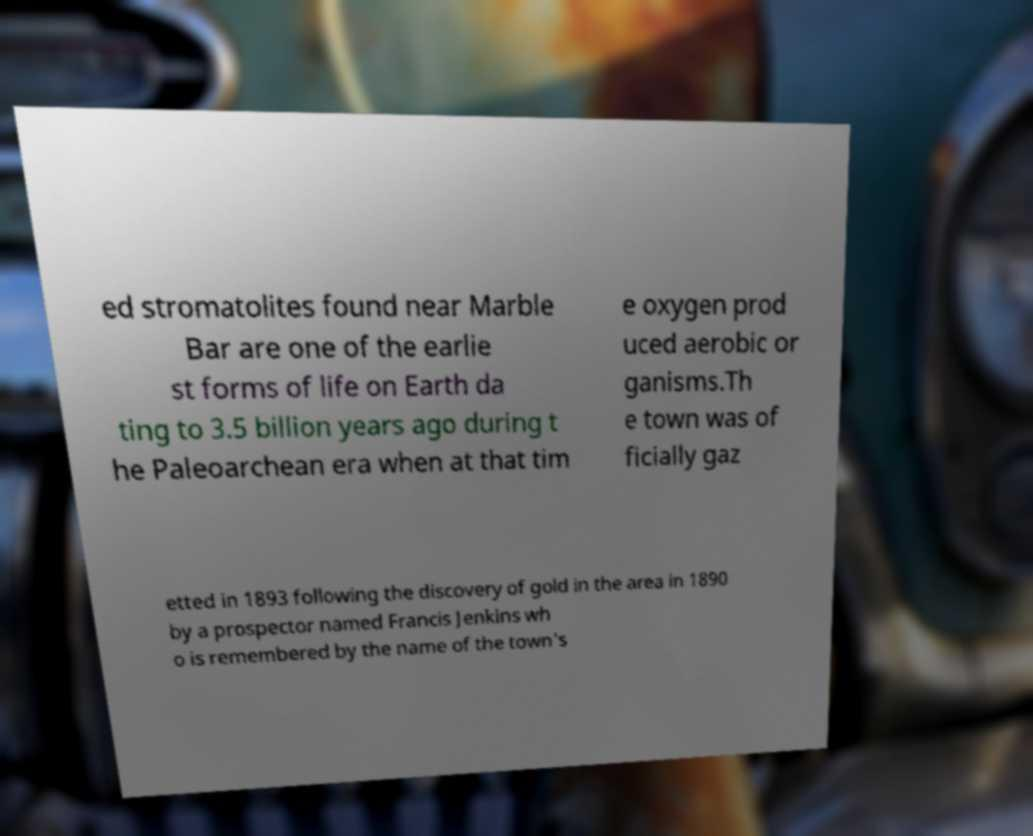Can you accurately transcribe the text from the provided image for me? ed stromatolites found near Marble Bar are one of the earlie st forms of life on Earth da ting to 3.5 billion years ago during t he Paleoarchean era when at that tim e oxygen prod uced aerobic or ganisms.Th e town was of ficially gaz etted in 1893 following the discovery of gold in the area in 1890 by a prospector named Francis Jenkins wh o is remembered by the name of the town's 